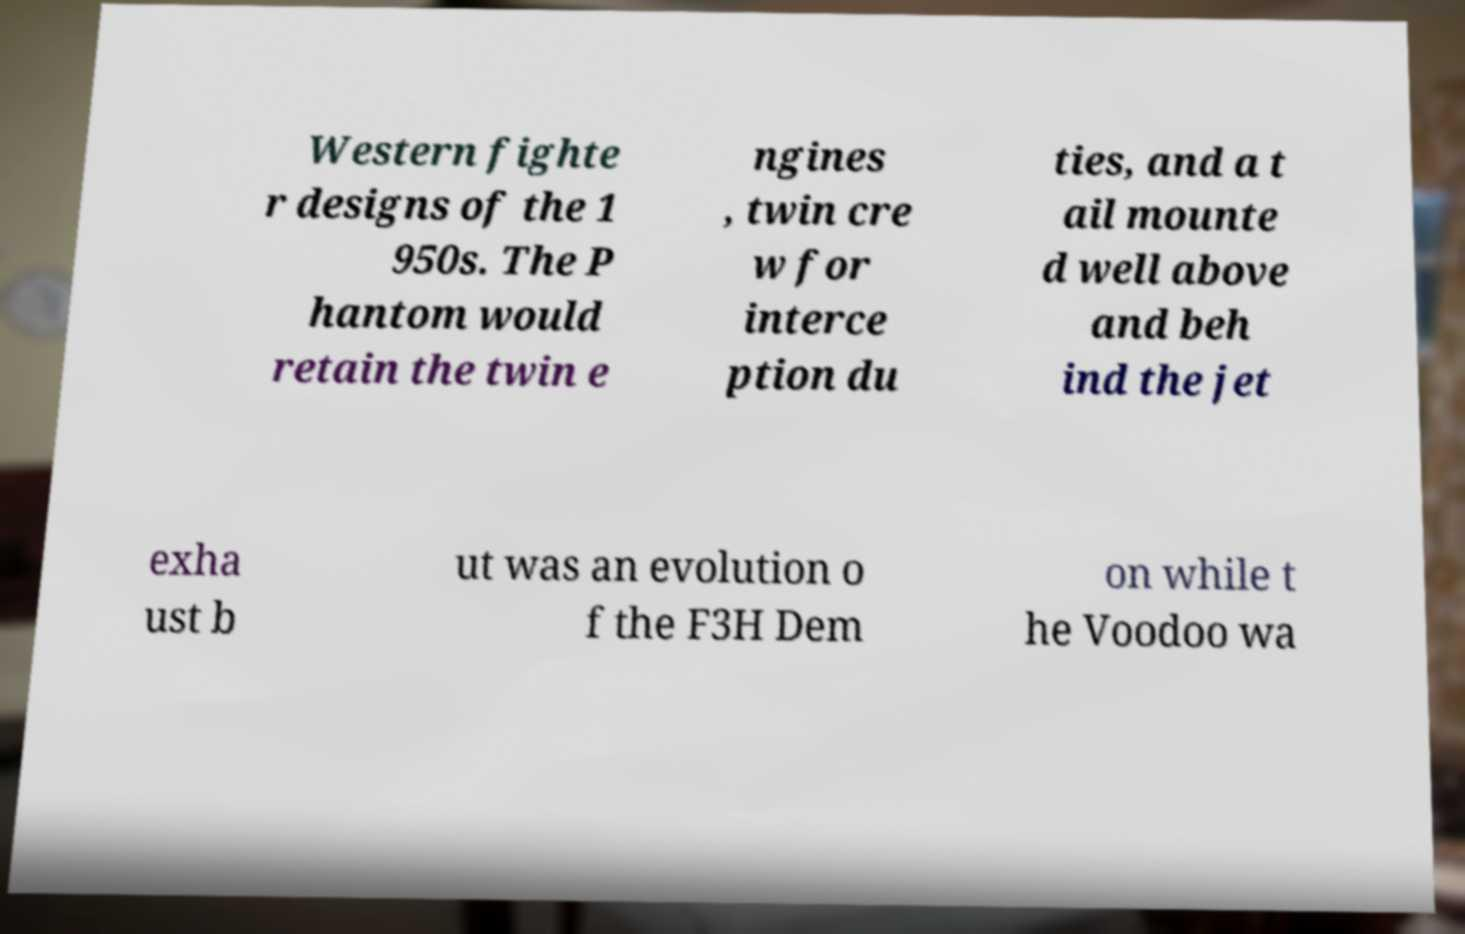Can you accurately transcribe the text from the provided image for me? Western fighte r designs of the 1 950s. The P hantom would retain the twin e ngines , twin cre w for interce ption du ties, and a t ail mounte d well above and beh ind the jet exha ust b ut was an evolution o f the F3H Dem on while t he Voodoo wa 